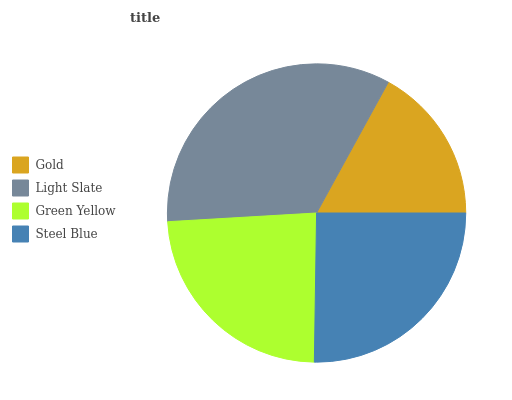Is Gold the minimum?
Answer yes or no. Yes. Is Light Slate the maximum?
Answer yes or no. Yes. Is Green Yellow the minimum?
Answer yes or no. No. Is Green Yellow the maximum?
Answer yes or no. No. Is Light Slate greater than Green Yellow?
Answer yes or no. Yes. Is Green Yellow less than Light Slate?
Answer yes or no. Yes. Is Green Yellow greater than Light Slate?
Answer yes or no. No. Is Light Slate less than Green Yellow?
Answer yes or no. No. Is Steel Blue the high median?
Answer yes or no. Yes. Is Green Yellow the low median?
Answer yes or no. Yes. Is Light Slate the high median?
Answer yes or no. No. Is Steel Blue the low median?
Answer yes or no. No. 